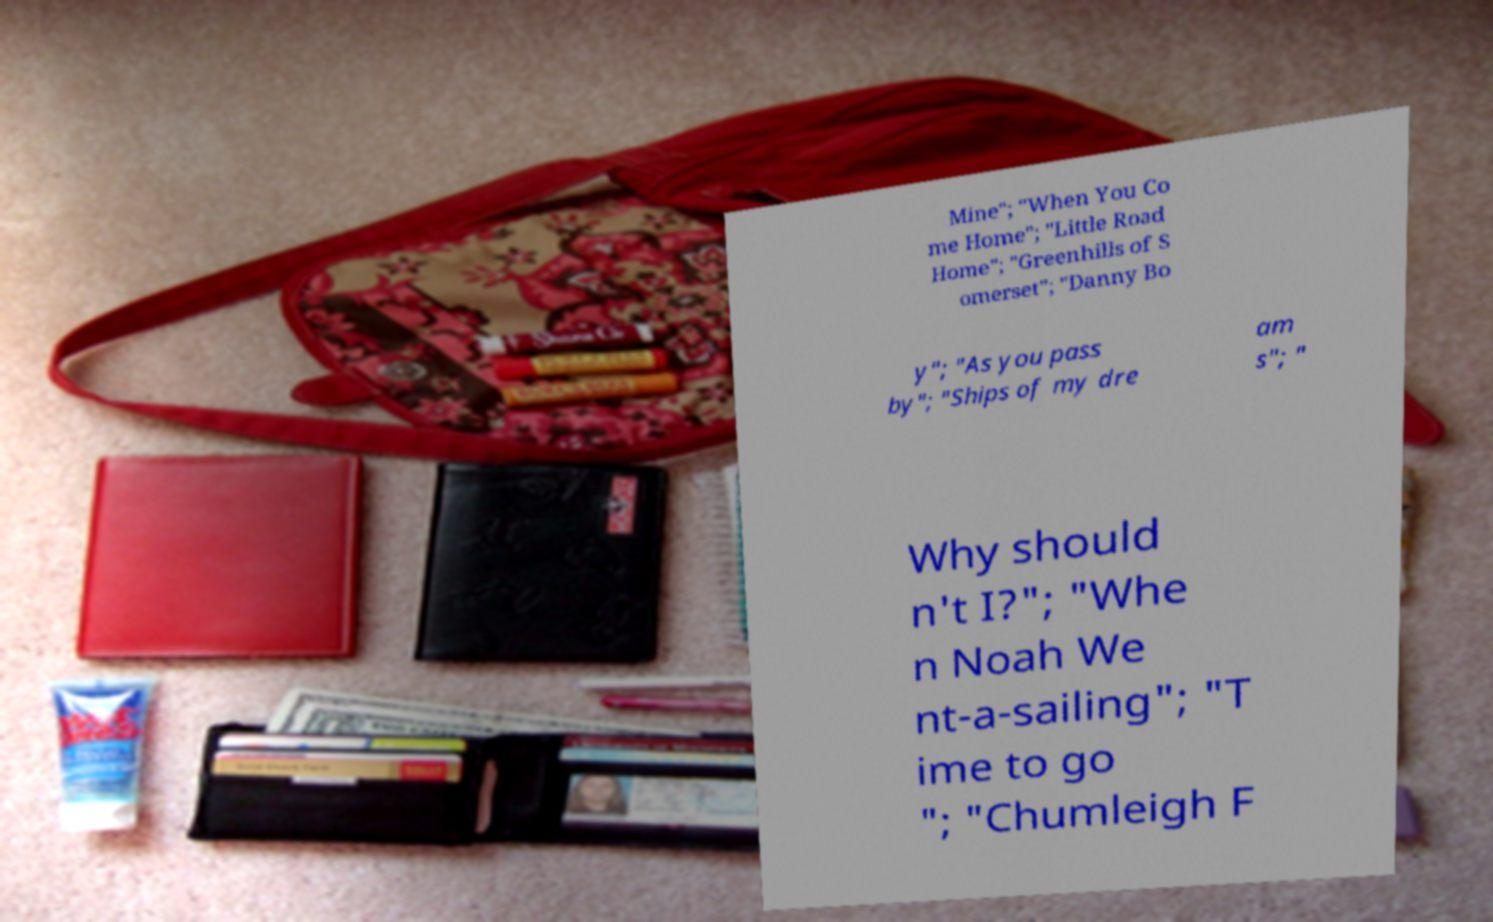I need the written content from this picture converted into text. Can you do that? Mine"; "When You Co me Home"; "Little Road Home"; "Greenhills of S omerset"; "Danny Bo y"; "As you pass by"; "Ships of my dre am s"; " Why should n't I?"; "Whe n Noah We nt-a-sailing"; "T ime to go "; "Chumleigh F 